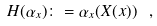<formula> <loc_0><loc_0><loc_500><loc_500>H ( \alpha _ { x } ) \colon = \alpha _ { x } ( { X } ( x ) ) \ ,</formula> 